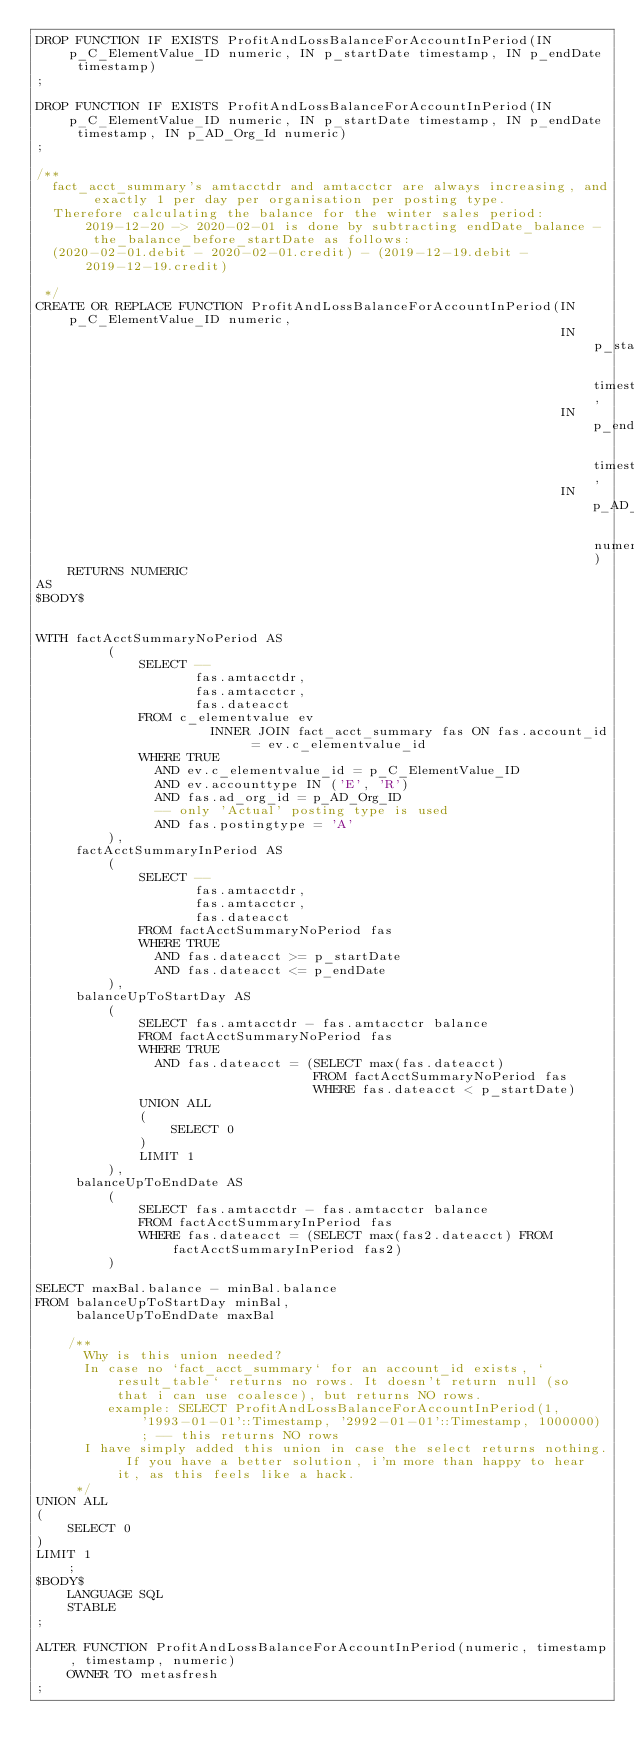<code> <loc_0><loc_0><loc_500><loc_500><_SQL_>DROP FUNCTION IF EXISTS ProfitAndLossBalanceForAccountInPeriod(IN p_C_ElementValue_ID numeric, IN p_startDate timestamp, IN p_endDate timestamp)
;

DROP FUNCTION IF EXISTS ProfitAndLossBalanceForAccountInPeriod(IN p_C_ElementValue_ID numeric, IN p_startDate timestamp, IN p_endDate timestamp, IN p_AD_Org_Id numeric)
;

/**
  fact_acct_summary's amtacctdr and amtacctcr are always increasing, and exactly 1 per day per organisation per posting type.
  Therefore calculating the balance for the winter sales period: 2019-12-20 -> 2020-02-01 is done by subtracting endDate_balance - the_balance_before_startDate as follows:
  (2020-02-01.debit - 2020-02-01.credit) - (2019-12-19.debit - 2019-12-19.credit)

 */
CREATE OR REPLACE FUNCTION ProfitAndLossBalanceForAccountInPeriod(IN p_C_ElementValue_ID numeric,
                                                                  IN p_startDate         timestamp,
                                                                  IN p_endDate           timestamp,
                                                                  IN p_AD_Org_Id         numeric)
    RETURNS NUMERIC
AS
$BODY$


WITH factAcctSummaryNoPeriod AS
         (
             SELECT --
                    fas.amtacctdr,
                    fas.amtacctcr,
                    fas.dateacct
             FROM c_elementvalue ev
                      INNER JOIN fact_acct_summary fas ON fas.account_id = ev.c_elementvalue_id
             WHERE TRUE
               AND ev.c_elementvalue_id = p_C_ElementValue_ID
               AND ev.accounttype IN ('E', 'R')
               AND fas.ad_org_id = p_AD_Org_ID
               -- only 'Actual' posting type is used
               AND fas.postingtype = 'A'
         ),
     factAcctSummaryInPeriod AS
         (
             SELECT --
                    fas.amtacctdr,
                    fas.amtacctcr,
                    fas.dateacct
             FROM factAcctSummaryNoPeriod fas
             WHERE TRUE
               AND fas.dateacct >= p_startDate
               AND fas.dateacct <= p_endDate
         ),
     balanceUpToStartDay AS
         (
             SELECT fas.amtacctdr - fas.amtacctcr balance
             FROM factAcctSummaryNoPeriod fas
             WHERE TRUE
               AND fas.dateacct = (SELECT max(fas.dateacct)
                                   FROM factAcctSummaryNoPeriod fas
                                   WHERE fas.dateacct < p_startDate)
             UNION ALL
             (
                 SELECT 0
             )
             LIMIT 1
         ),
     balanceUpToEndDate AS
         (
             SELECT fas.amtacctdr - fas.amtacctcr balance
             FROM factAcctSummaryInPeriod fas
             WHERE fas.dateacct = (SELECT max(fas2.dateacct) FROM factAcctSummaryInPeriod fas2)
         )

SELECT maxBal.balance - minBal.balance
FROM balanceUpToStartDay minBal,
     balanceUpToEndDate maxBal

    /**
      Why is this union needed?
      In case no `fact_acct_summary` for an account_id exists, `result_table` returns no rows. It doesn't return null (so that i can use coalesce), but returns NO rows.
         example: SELECT ProfitAndLossBalanceForAccountInPeriod(1, '1993-01-01'::Timestamp, '2992-01-01'::Timestamp, 1000000); -- this returns NO rows
      I have simply added this union in case the select returns nothing. If you have a better solution, i'm more than happy to hear it, as this feels like a hack.
     */
UNION ALL
(
    SELECT 0
)
LIMIT 1
    ;
$BODY$
    LANGUAGE SQL
    STABLE
;

ALTER FUNCTION ProfitAndLossBalanceForAccountInPeriod(numeric, timestamp, timestamp, numeric)
    OWNER TO metasfresh
;
</code> 